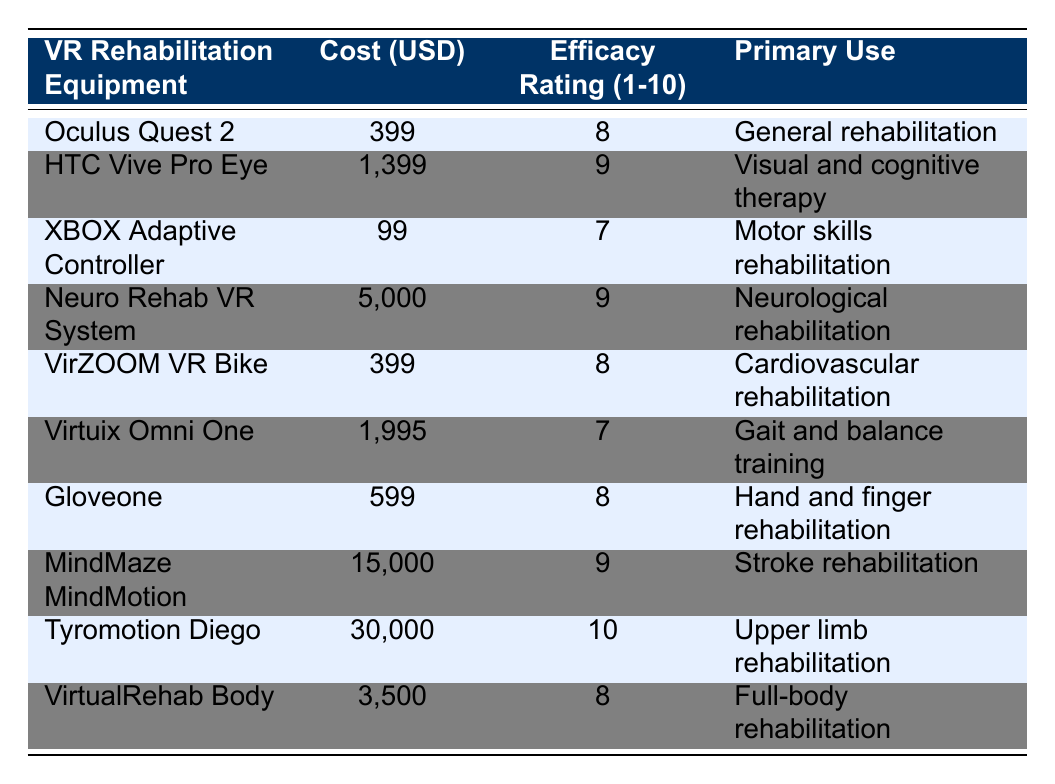What is the cost of the Neuro Rehab VR System? The table lists the cost of the Neuro Rehab VR System as 5000 USD, which can be found in the 'Cost (USD)' column corresponding to that piece of equipment.
Answer: 5000 USD What is the efficacy rating of the Tyromotion Diego? The table shows the efficacy rating of the Tyromotion Diego as 10, found in the 'Efficacy Rating (1-10)' column.
Answer: 10 Which VR rehabilitation equipment has the highest efficacy rating? Tyromotion Diego has the highest efficacy rating of 10 according to the 'Efficacy Rating (1-10)' column.
Answer: Tyromotion Diego What is the total cost of the equipment with an efficacy rating of 9? The equipment with an efficacy rating of 9 includes HTC Vive Pro Eye (1399 USD), Neuro Rehab VR System (5000 USD), and MindMaze MindMotion (15000 USD). Summing these: 1399 + 5000 + 15000 = 21399 USD.
Answer: 21399 USD Is the XBOX Adaptive Controller used for visual therapy? The primary use of the XBOX Adaptive Controller is listed as "Motor skills rehabilitation," indicating it is not used for visual therapy.
Answer: No How much more expensive is the Tyromotion Diego compared to the Oculus Quest 2? The Tyromotion Diego costs 30000 USD and the Oculus Quest 2 costs 399 USD. The difference is 30000 - 399 = 29601 USD.
Answer: 29601 USD What proportion of the equipment listed is used for rehabilitation of the upper limbs? Only the Tyromotion Diego is explicitly listed for upper limb rehabilitation among the 10 pieces of equipment. Therefore, the proportion is 1 out of 10, which is 10%.
Answer: 10% Which two pieces of equipment have the same efficacy rating? Both Oculus Quest 2 and VirZOOM VR Bike have an efficacy rating of 8, which can be found by comparing their respective columns.
Answer: Oculus Quest 2 and VirZOOM VR Bike What is the average cost of the VR rehabilitation equipment listed? To find the average, sum all the costs: 399 + 1399 + 99 + 5000 + 399 + 1995 + 599 + 15000 + 30000 + 3500 = 52789 USD. Then divide by the number of items, which is 10: 52789 / 10 = 5278.9 USD.
Answer: 5278.9 USD 